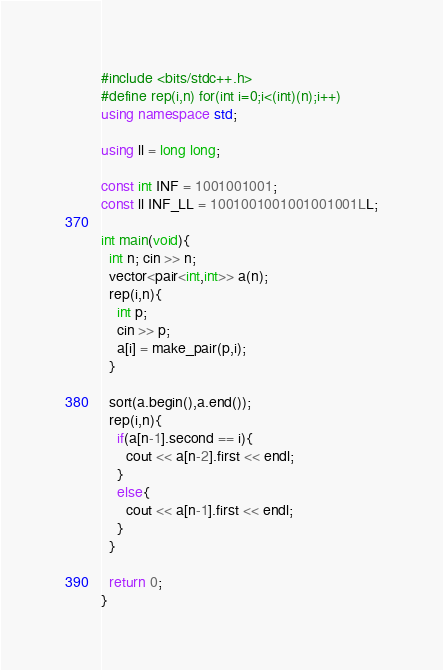<code> <loc_0><loc_0><loc_500><loc_500><_C++_>#include <bits/stdc++.h>
#define rep(i,n) for(int i=0;i<(int)(n);i++)
using namespace std;

using ll = long long;

const int INF = 1001001001;
const ll INF_LL = 1001001001001001001LL;

int main(void){
  int n; cin >> n;
  vector<pair<int,int>> a(n);
  rep(i,n){
    int p;
    cin >> p;
    a[i] = make_pair(p,i);
  }

  sort(a.begin(),a.end());
  rep(i,n){
    if(a[n-1].second == i){
      cout << a[n-2].first << endl;
    }
    else{
      cout << a[n-1].first << endl;
    }
  }
  
  return 0;
}
</code> 